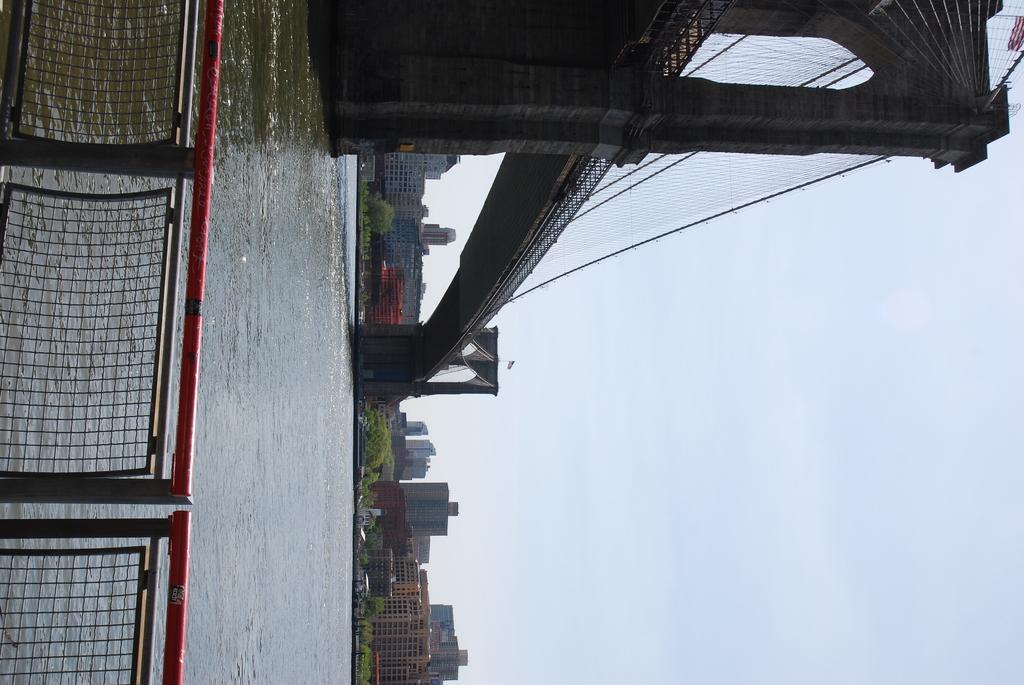How would you summarize this image in a sentence or two? In this image we can see water, railing, bridge, trees, and buildings. On the right side of the image we can see sky. 